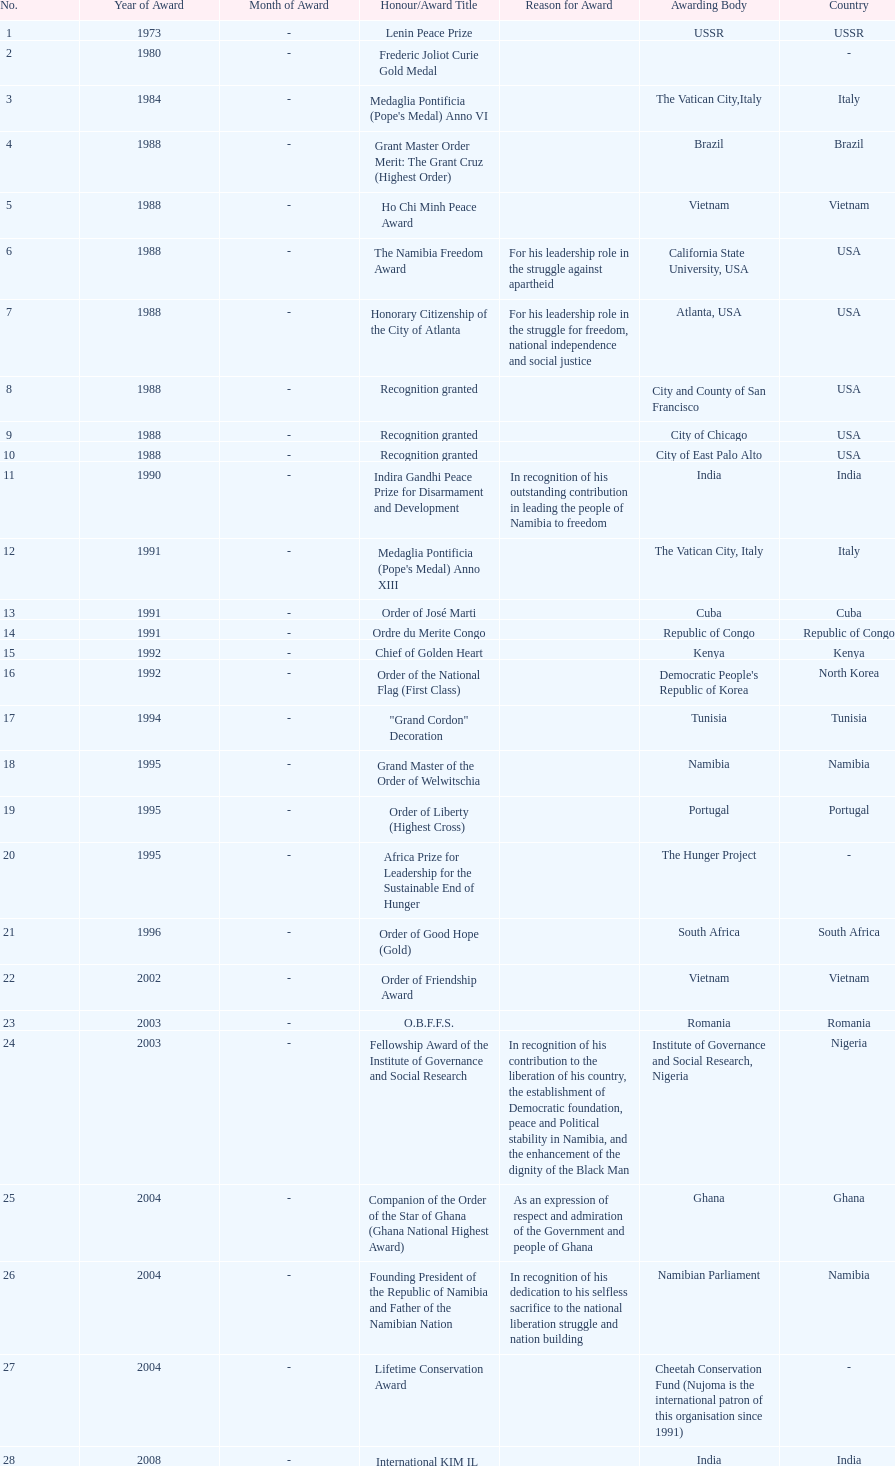The number of times "recognition granted" was the received award? 3. 